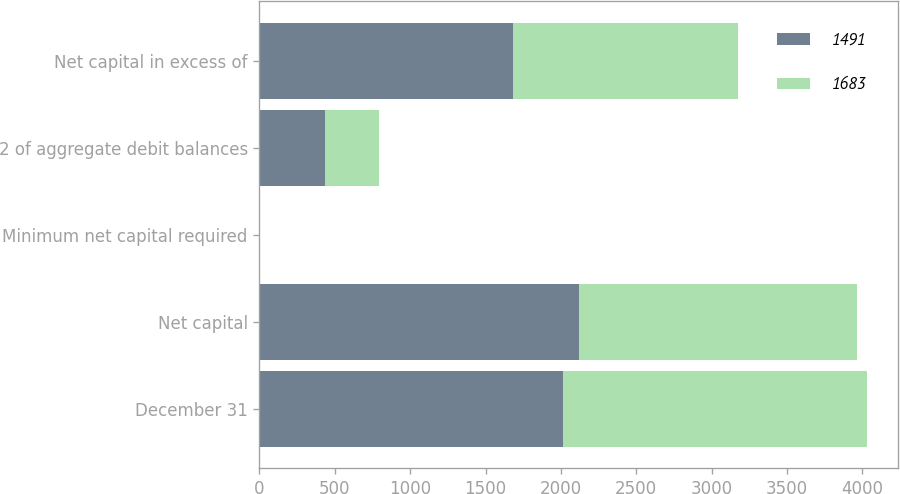Convert chart. <chart><loc_0><loc_0><loc_500><loc_500><stacked_bar_chart><ecel><fcel>December 31<fcel>Net capital<fcel>Minimum net capital required<fcel>2 of aggregate debit balances<fcel>Net capital in excess of<nl><fcel>1491<fcel>2017<fcel>2118<fcel>0.25<fcel>435<fcel>1683<nl><fcel>1683<fcel>2016<fcel>1846<fcel>0.25<fcel>355<fcel>1491<nl></chart> 